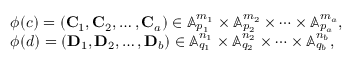Convert formula to latex. <formula><loc_0><loc_0><loc_500><loc_500>\begin{array} { r l } & { \phi ( c ) = \left ( C _ { 1 } , C _ { 2 } , \dots , C _ { a } \right ) \in \mathbb { A } _ { p _ { 1 } } ^ { m _ { 1 } } \times \mathbb { A } _ { p _ { 2 } } ^ { m _ { 2 } } \times \dots \times \mathbb { A } _ { p _ { a } } ^ { m _ { a } } , } \\ & { \phi ( d ) = \left ( D _ { 1 } , D _ { 2 } , \dots , D _ { b } \right ) \in \mathbb { A } _ { q _ { 1 } } ^ { n _ { 1 } } \times \mathbb { A } _ { q _ { 2 } } ^ { n _ { 2 } } \times \dots \times \mathbb { A } _ { q _ { b } } ^ { n _ { b } } , } \end{array}</formula> 